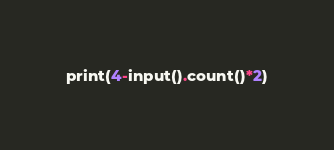Convert code to text. <code><loc_0><loc_0><loc_500><loc_500><_Python_>print(4-input().count()*2)</code> 